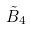<formula> <loc_0><loc_0><loc_500><loc_500>\tilde { B } _ { 4 }</formula> 